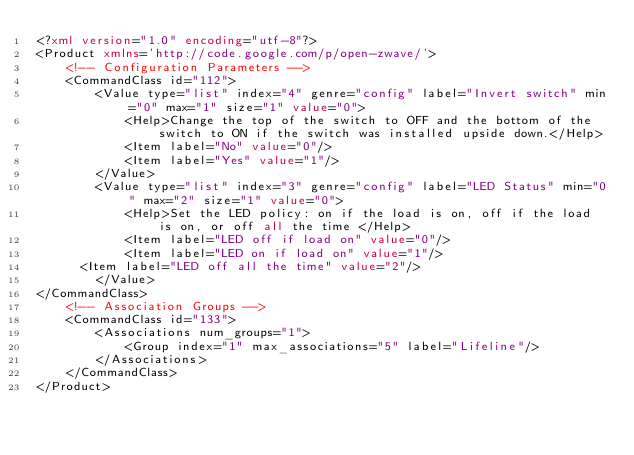<code> <loc_0><loc_0><loc_500><loc_500><_XML_><?xml version="1.0" encoding="utf-8"?>
<Product xmlns='http://code.google.com/p/open-zwave/'>
    <!-- Configuration Parameters -->
    <CommandClass id="112">
        <Value type="list" index="4" genre="config" label="Invert switch" min="0" max="1" size="1" value="0">
            <Help>Change the top of the switch to OFF and the bottom of the switch to ON if the switch was installed upside down.</Help>
            <Item label="No" value="0"/>
            <Item label="Yes" value="1"/>
        </Value>
        <Value type="list" index="3" genre="config" label="LED Status" min="0" max="2" size="1" value="0">
            <Help>Set the LED policy: on if the load is on, off if the load is on, or off all the time </Help>
            <Item label="LED off if load on" value="0"/>
            <Item label="LED on if load on" value="1"/>
	    <Item label="LED off all the time" value="2"/>
        </Value>
</CommandClass>
    <!-- Association Groups -->
    <CommandClass id="133">
        <Associations num_groups="1">
            <Group index="1" max_associations="5" label="Lifeline"/>
        </Associations>
    </CommandClass>
</Product>
</code> 